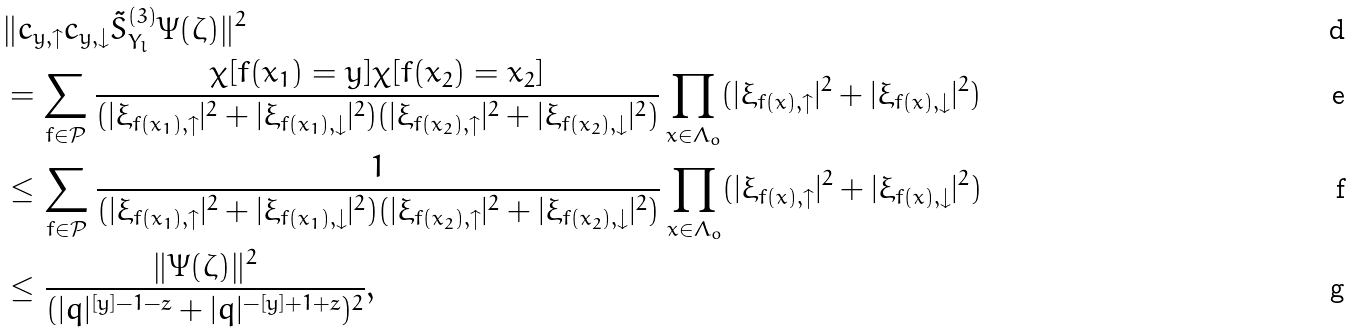<formula> <loc_0><loc_0><loc_500><loc_500>& \| c _ { y , \uparrow } c _ { y , \downarrow } \tilde { S } ^ { ( 3 ) } _ { Y _ { l } } \Psi ( \zeta ) \| ^ { 2 } \\ & = \sum _ { f \in \mathcal { P } } \frac { \chi [ f ( x _ { 1 } ) = y ] \chi [ f ( x _ { 2 } ) = x _ { 2 } ] } { ( | \xi _ { f ( x _ { 1 } ) , \uparrow } | ^ { 2 } + | \xi _ { f ( x _ { 1 } ) , \downarrow } | ^ { 2 } ) ( | \xi _ { f ( x _ { 2 } ) , \uparrow } | ^ { 2 } + | \xi _ { f ( x _ { 2 } ) , \downarrow } | ^ { 2 } ) } \prod _ { x \in \Lambda _ { o } } ( | \xi _ { f ( x ) , \uparrow } | ^ { 2 } + | \xi _ { f ( x ) , \downarrow } | ^ { 2 } ) \\ & \leq \sum _ { f \in \mathcal { P } } \frac { 1 } { ( | \xi _ { f ( x _ { 1 } ) , \uparrow } | ^ { 2 } + | \xi _ { f ( x _ { 1 } ) , \downarrow } | ^ { 2 } ) ( | \xi _ { f ( x _ { 2 } ) , \uparrow } | ^ { 2 } + | \xi _ { f ( x _ { 2 } ) , \downarrow } | ^ { 2 } ) } \prod _ { x \in \Lambda _ { o } } ( | \xi _ { f ( x ) , \uparrow } | ^ { 2 } + | \xi _ { f ( x ) , \downarrow } | ^ { 2 } ) \\ & \leq \frac { \| \Psi ( \zeta ) \| ^ { 2 } } { ( | q | ^ { [ y ] - 1 - z } + | q | ^ { - [ y ] + 1 + z } ) ^ { 2 } } ,</formula> 